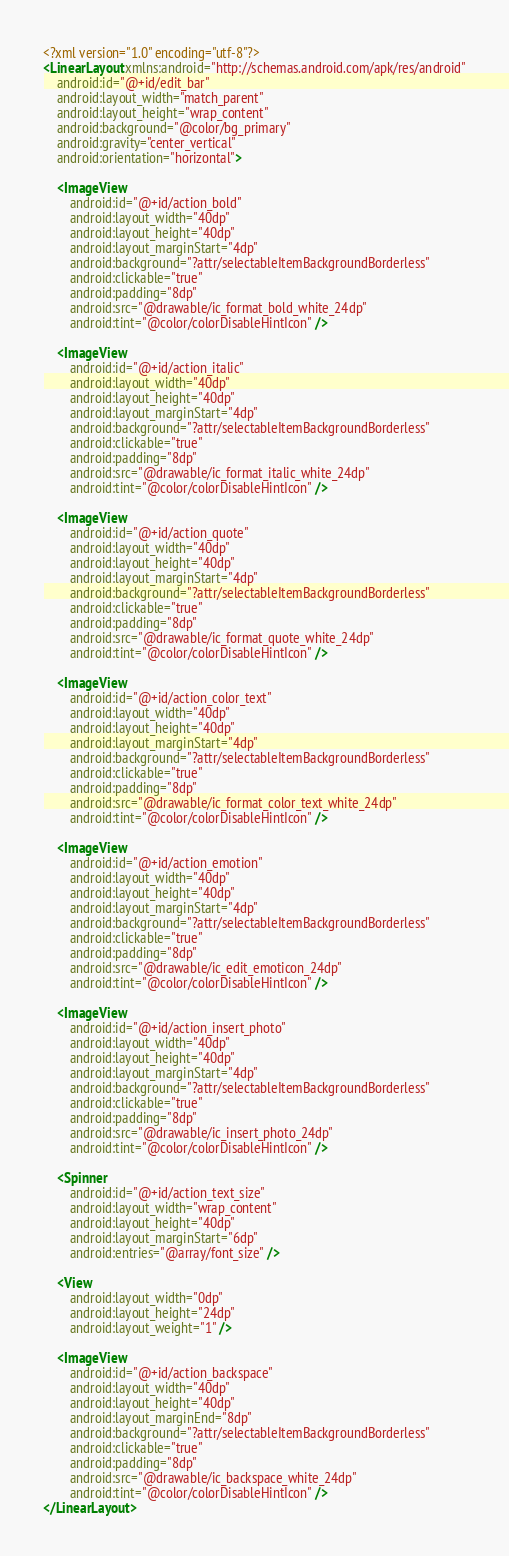<code> <loc_0><loc_0><loc_500><loc_500><_XML_><?xml version="1.0" encoding="utf-8"?>
<LinearLayout xmlns:android="http://schemas.android.com/apk/res/android"
    android:id="@+id/edit_bar"
    android:layout_width="match_parent"
    android:layout_height="wrap_content"
    android:background="@color/bg_primary"
    android:gravity="center_vertical"
    android:orientation="horizontal">

    <ImageView
        android:id="@+id/action_bold"
        android:layout_width="40dp"
        android:layout_height="40dp"
        android:layout_marginStart="4dp"
        android:background="?attr/selectableItemBackgroundBorderless"
        android:clickable="true"
        android:padding="8dp"
        android:src="@drawable/ic_format_bold_white_24dp"
        android:tint="@color/colorDisableHintIcon" />

    <ImageView
        android:id="@+id/action_italic"
        android:layout_width="40dp"
        android:layout_height="40dp"
        android:layout_marginStart="4dp"
        android:background="?attr/selectableItemBackgroundBorderless"
        android:clickable="true"
        android:padding="8dp"
        android:src="@drawable/ic_format_italic_white_24dp"
        android:tint="@color/colorDisableHintIcon" />

    <ImageView
        android:id="@+id/action_quote"
        android:layout_width="40dp"
        android:layout_height="40dp"
        android:layout_marginStart="4dp"
        android:background="?attr/selectableItemBackgroundBorderless"
        android:clickable="true"
        android:padding="8dp"
        android:src="@drawable/ic_format_quote_white_24dp"
        android:tint="@color/colorDisableHintIcon" />

    <ImageView
        android:id="@+id/action_color_text"
        android:layout_width="40dp"
        android:layout_height="40dp"
        android:layout_marginStart="4dp"
        android:background="?attr/selectableItemBackgroundBorderless"
        android:clickable="true"
        android:padding="8dp"
        android:src="@drawable/ic_format_color_text_white_24dp"
        android:tint="@color/colorDisableHintIcon" />

    <ImageView
        android:id="@+id/action_emotion"
        android:layout_width="40dp"
        android:layout_height="40dp"
        android:layout_marginStart="4dp"
        android:background="?attr/selectableItemBackgroundBorderless"
        android:clickable="true"
        android:padding="8dp"
        android:src="@drawable/ic_edit_emoticon_24dp"
        android:tint="@color/colorDisableHintIcon" />

    <ImageView
        android:id="@+id/action_insert_photo"
        android:layout_width="40dp"
        android:layout_height="40dp"
        android:layout_marginStart="4dp"
        android:background="?attr/selectableItemBackgroundBorderless"
        android:clickable="true"
        android:padding="8dp"
        android:src="@drawable/ic_insert_photo_24dp"
        android:tint="@color/colorDisableHintIcon" />

    <Spinner
        android:id="@+id/action_text_size"
        android:layout_width="wrap_content"
        android:layout_height="40dp"
        android:layout_marginStart="6dp"
        android:entries="@array/font_size" />

    <View
        android:layout_width="0dp"
        android:layout_height="24dp"
        android:layout_weight="1" />

    <ImageView
        android:id="@+id/action_backspace"
        android:layout_width="40dp"
        android:layout_height="40dp"
        android:layout_marginEnd="8dp"
        android:background="?attr/selectableItemBackgroundBorderless"
        android:clickable="true"
        android:padding="8dp"
        android:src="@drawable/ic_backspace_white_24dp"
        android:tint="@color/colorDisableHintIcon" />
</LinearLayout>



</code> 